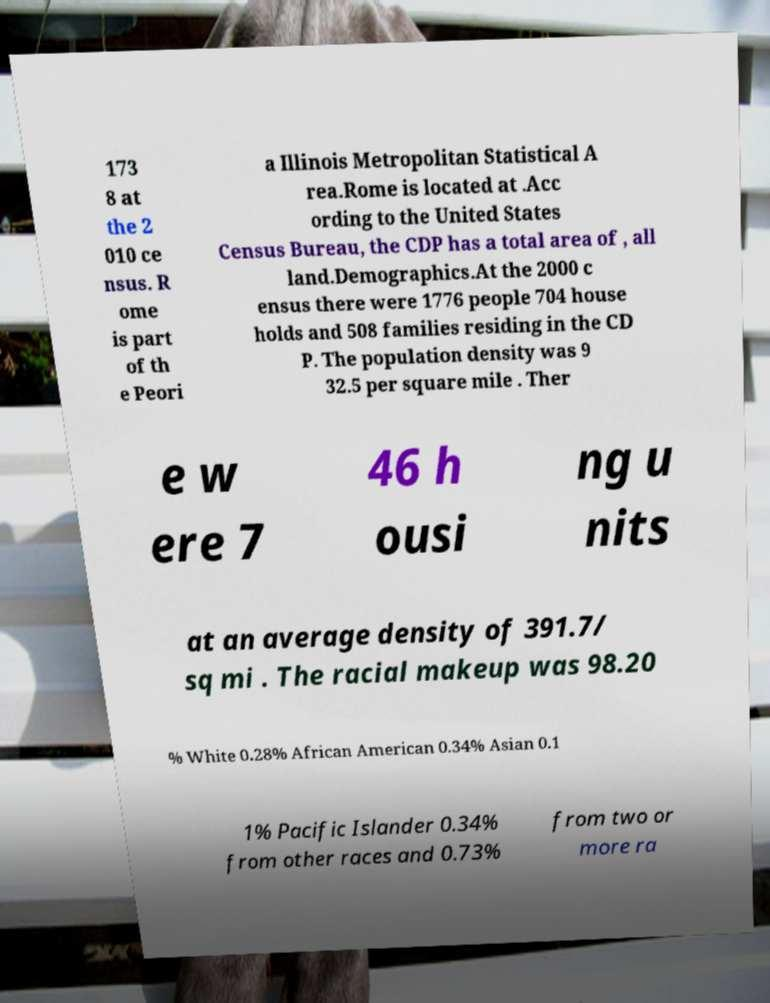Could you extract and type out the text from this image? 173 8 at the 2 010 ce nsus. R ome is part of th e Peori a Illinois Metropolitan Statistical A rea.Rome is located at .Acc ording to the United States Census Bureau, the CDP has a total area of , all land.Demographics.At the 2000 c ensus there were 1776 people 704 house holds and 508 families residing in the CD P. The population density was 9 32.5 per square mile . Ther e w ere 7 46 h ousi ng u nits at an average density of 391.7/ sq mi . The racial makeup was 98.20 % White 0.28% African American 0.34% Asian 0.1 1% Pacific Islander 0.34% from other races and 0.73% from two or more ra 